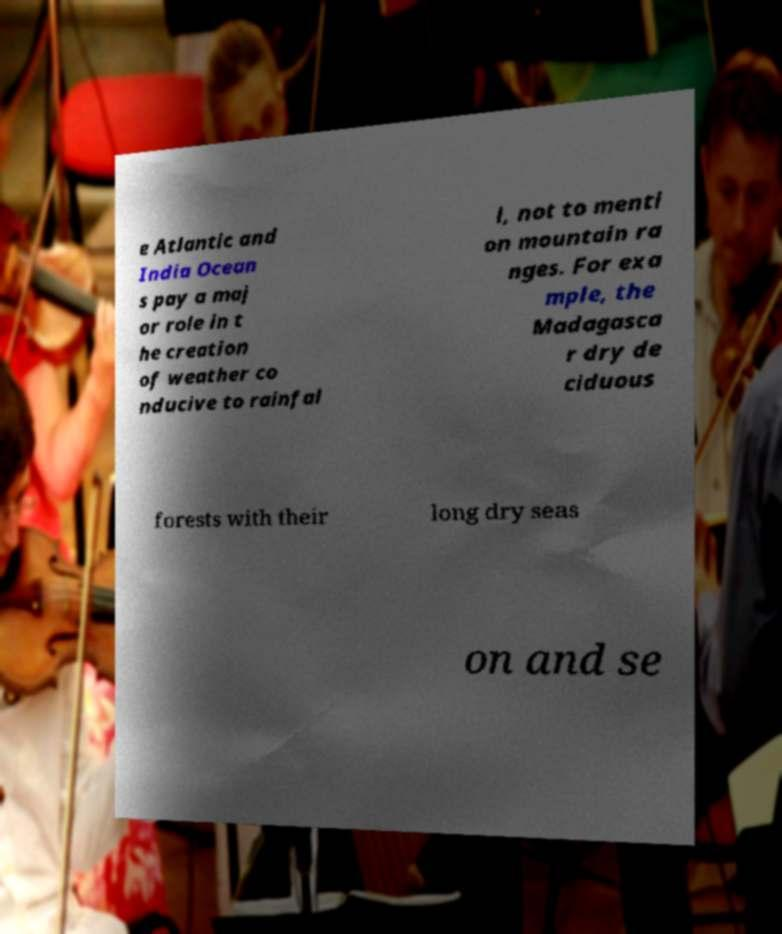Can you read and provide the text displayed in the image?This photo seems to have some interesting text. Can you extract and type it out for me? e Atlantic and India Ocean s pay a maj or role in t he creation of weather co nducive to rainfal l, not to menti on mountain ra nges. For exa mple, the Madagasca r dry de ciduous forests with their long dry seas on and se 